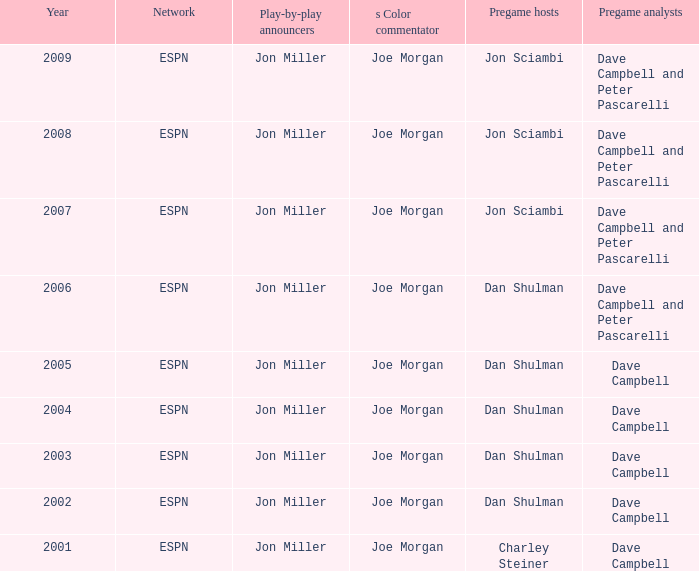How many networks are itemized during 2008? 1.0. 